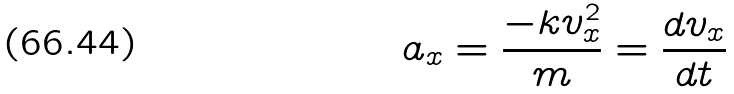Convert formula to latex. <formula><loc_0><loc_0><loc_500><loc_500>a _ { x } = \frac { - k v _ { x } ^ { 2 } } { m } = \frac { d v _ { x } } { d t }</formula> 